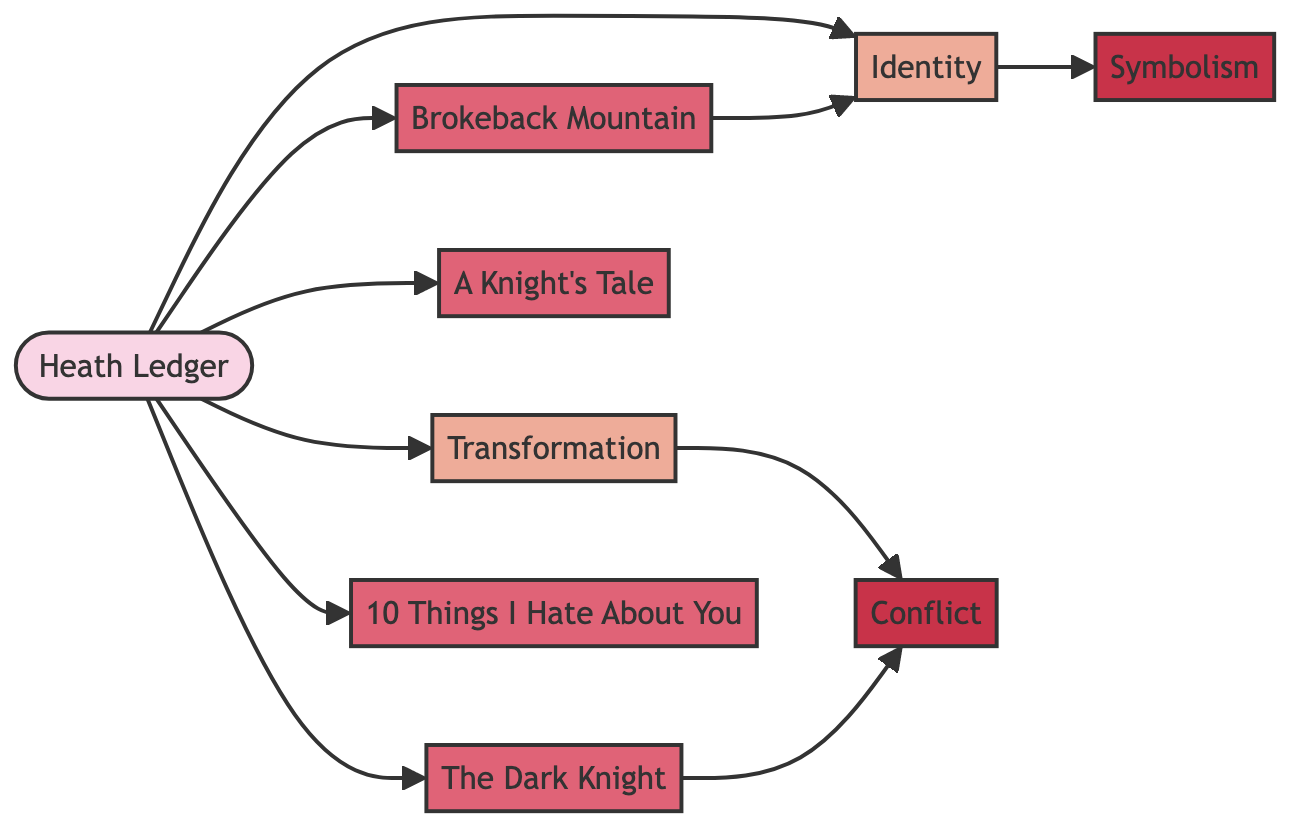What is the total number of nodes in the diagram? To find the total number of nodes, we count each unique node listed in the data: Heath Ledger, Identity, Transformation, The Dark Knight, A Knight's Tale, Brokeback Mountain, 10 Things I Hate About You, Symbolism, and Conflict. This gives us a total of 9 nodes.
Answer: 9 Which movie is connected to the theme of Identity? By examining the edges that connect to the Identity node, we see that both Brokeback Mountain and Heath Ledger are directly connected to Identity. Thus, Brokeback Mountain is a movie connected to this theme.
Answer: Brokeback Mountain How many edges connect to the node representing Transformation? Looking at the edges emanating from the Transformation node, there is one edge connecting it to Conflict. Therefore, there is only one edge.
Answer: 1 What thematic element is related to The Dark Knight? The Dark Knight is connected to the Conflict node, indicating that Conflict is a thematic element related to this film.
Answer: Conflict What type of relationship connects Heath Ledger with his roles in films? Each film node (The Dark Knight, A Knight's Tale, Brokeback Mountain, and 10 Things I Hate About You) is directly connected to the Heath Ledger node, representing a direct relationship of his involvement in these films.
Answer: Direct involvement Which theme has a connection to Symbolism? The theme of Identity has a connection to Symbolism, as this is indicated by the edge leading from Identity to Symbolism in the diagram.
Answer: Identity Is there any movie that connects Identity and Transformation themes? The diagram does not show a direct connection between Identity and Transformation through any movie node, making them separate thematic paths without overlap. Therefore, no such movie exists.
Answer: No What common thematic element do The Dark Knight and Transformation share? Both The Dark Knight and Transformation share the thematic element of Conflict. This is displayed by their respective connections to the Conflict node in the graph.
Answer: Conflict 